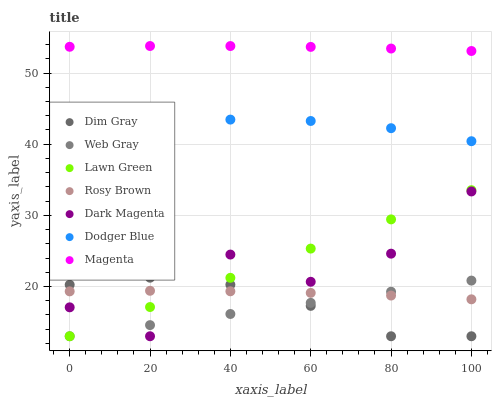Does Web Gray have the minimum area under the curve?
Answer yes or no. Yes. Does Magenta have the maximum area under the curve?
Answer yes or no. Yes. Does Dim Gray have the minimum area under the curve?
Answer yes or no. No. Does Dim Gray have the maximum area under the curve?
Answer yes or no. No. Is Lawn Green the smoothest?
Answer yes or no. Yes. Is Dark Magenta the roughest?
Answer yes or no. Yes. Is Dim Gray the smoothest?
Answer yes or no. No. Is Dim Gray the roughest?
Answer yes or no. No. Does Lawn Green have the lowest value?
Answer yes or no. Yes. Does Rosy Brown have the lowest value?
Answer yes or no. No. Does Magenta have the highest value?
Answer yes or no. Yes. Does Dim Gray have the highest value?
Answer yes or no. No. Is Dim Gray less than Dodger Blue?
Answer yes or no. Yes. Is Magenta greater than Dark Magenta?
Answer yes or no. Yes. Does Dim Gray intersect Web Gray?
Answer yes or no. Yes. Is Dim Gray less than Web Gray?
Answer yes or no. No. Is Dim Gray greater than Web Gray?
Answer yes or no. No. Does Dim Gray intersect Dodger Blue?
Answer yes or no. No. 